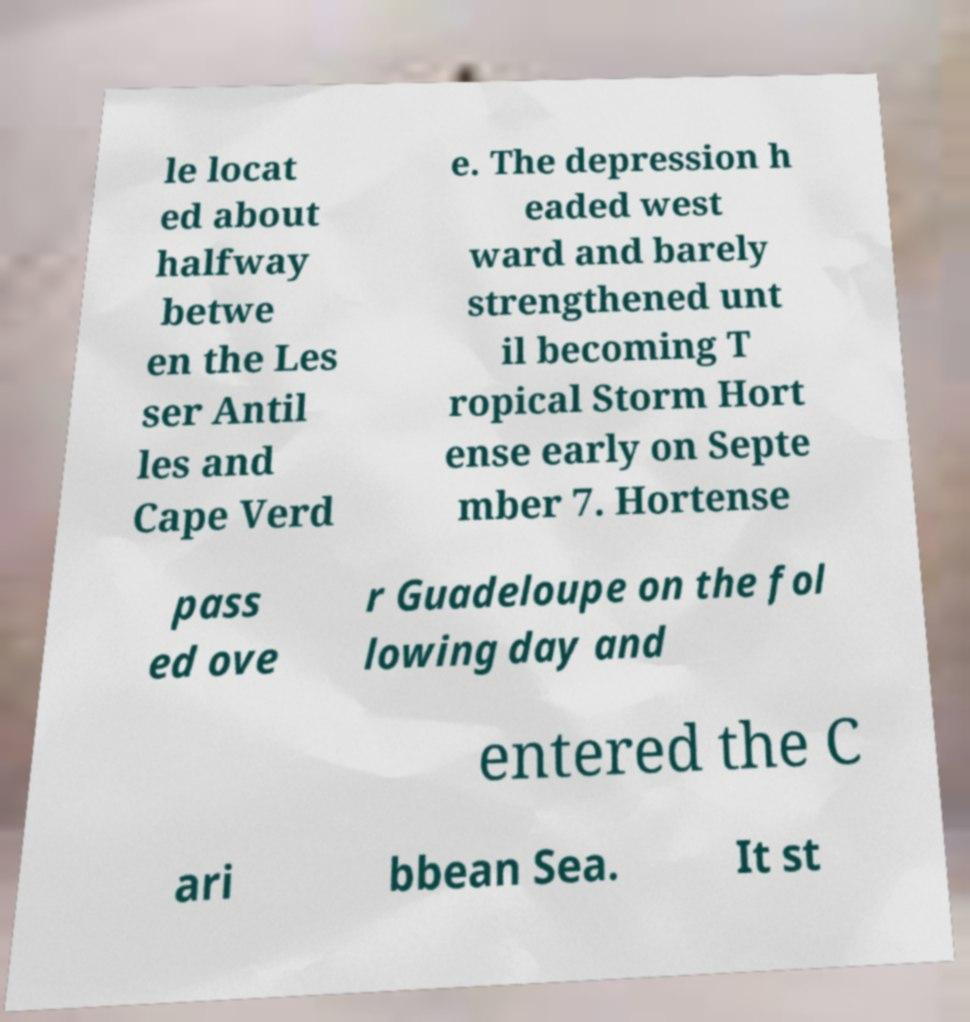What messages or text are displayed in this image? I need them in a readable, typed format. le locat ed about halfway betwe en the Les ser Antil les and Cape Verd e. The depression h eaded west ward and barely strengthened unt il becoming T ropical Storm Hort ense early on Septe mber 7. Hortense pass ed ove r Guadeloupe on the fol lowing day and entered the C ari bbean Sea. It st 